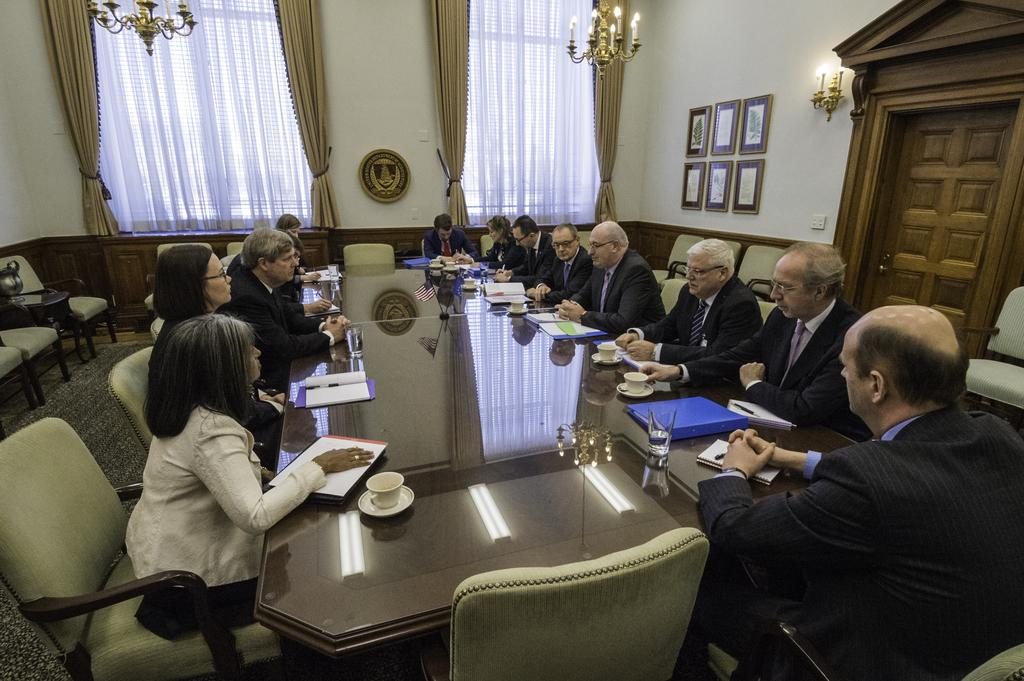What are the people in the image doing? There are persons sitting on chairs in the image. What objects can be seen on the table? There is a glass, a saucer, a cup, a paper, and a file on the table. How many windows are in the room? There are two windows in the room. What type of window treatment is present in the room? There are curtains associated with the windows. What other items can be seen in the room? There are photo frames in the room. Is there any entrance or exit in the room? Yes, there is a door in the room. What is the chance of winning the lottery in the image? There is no information about the lottery or any chances of winning in the image. What type of hat is the person wearing in the image? There are no hats visible in the image. 